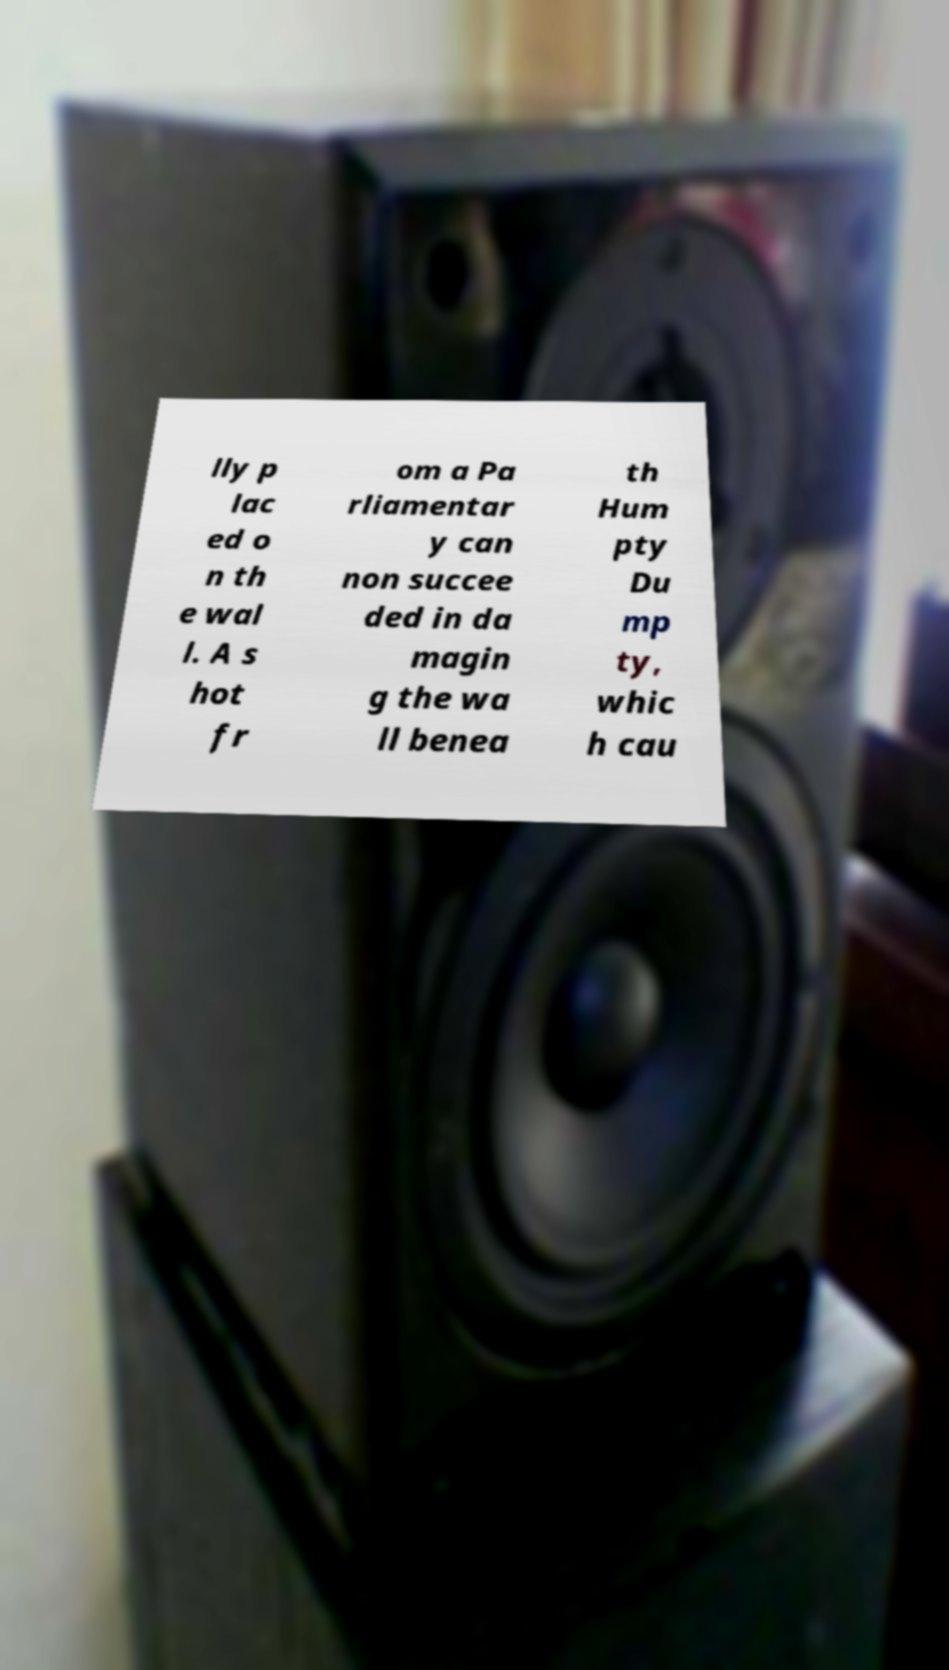Can you read and provide the text displayed in the image?This photo seems to have some interesting text. Can you extract and type it out for me? lly p lac ed o n th e wal l. A s hot fr om a Pa rliamentar y can non succee ded in da magin g the wa ll benea th Hum pty Du mp ty, whic h cau 